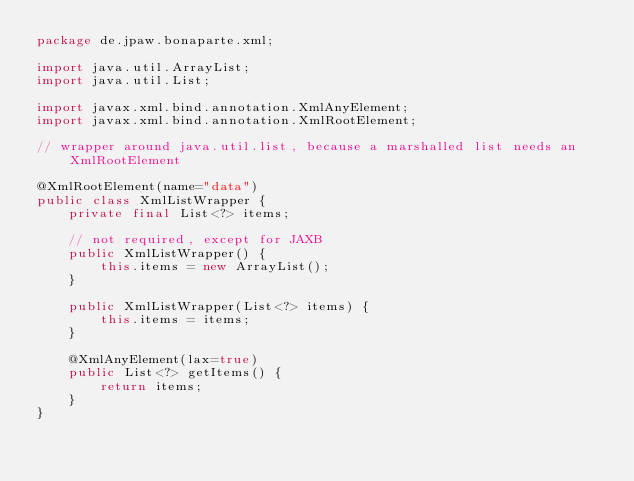<code> <loc_0><loc_0><loc_500><loc_500><_Java_>package de.jpaw.bonaparte.xml;

import java.util.ArrayList;
import java.util.List;

import javax.xml.bind.annotation.XmlAnyElement;
import javax.xml.bind.annotation.XmlRootElement;

// wrapper around java.util.list, because a marshalled list needs an XmlRootElement

@XmlRootElement(name="data")
public class XmlListWrapper {
    private final List<?> items;

    // not required, except for JAXB
    public XmlListWrapper() {
        this.items = new ArrayList();
    }

    public XmlListWrapper(List<?> items) {
        this.items = items;
    }

    @XmlAnyElement(lax=true)
    public List<?> getItems() {
        return items;
    }
}
</code> 